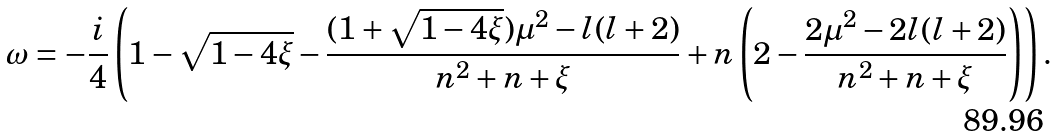Convert formula to latex. <formula><loc_0><loc_0><loc_500><loc_500>\omega = - \frac { i } { 4 } \left ( 1 - \sqrt { 1 - 4 \xi } - \frac { ( 1 + \sqrt { 1 - 4 \xi } ) \mu ^ { 2 } - l ( l + 2 ) } { n ^ { 2 } + n + \xi } + n \left ( 2 - \frac { 2 \mu ^ { 2 } - 2 l ( l + 2 ) } { n ^ { 2 } + n + \xi } \right ) \right ) .</formula> 